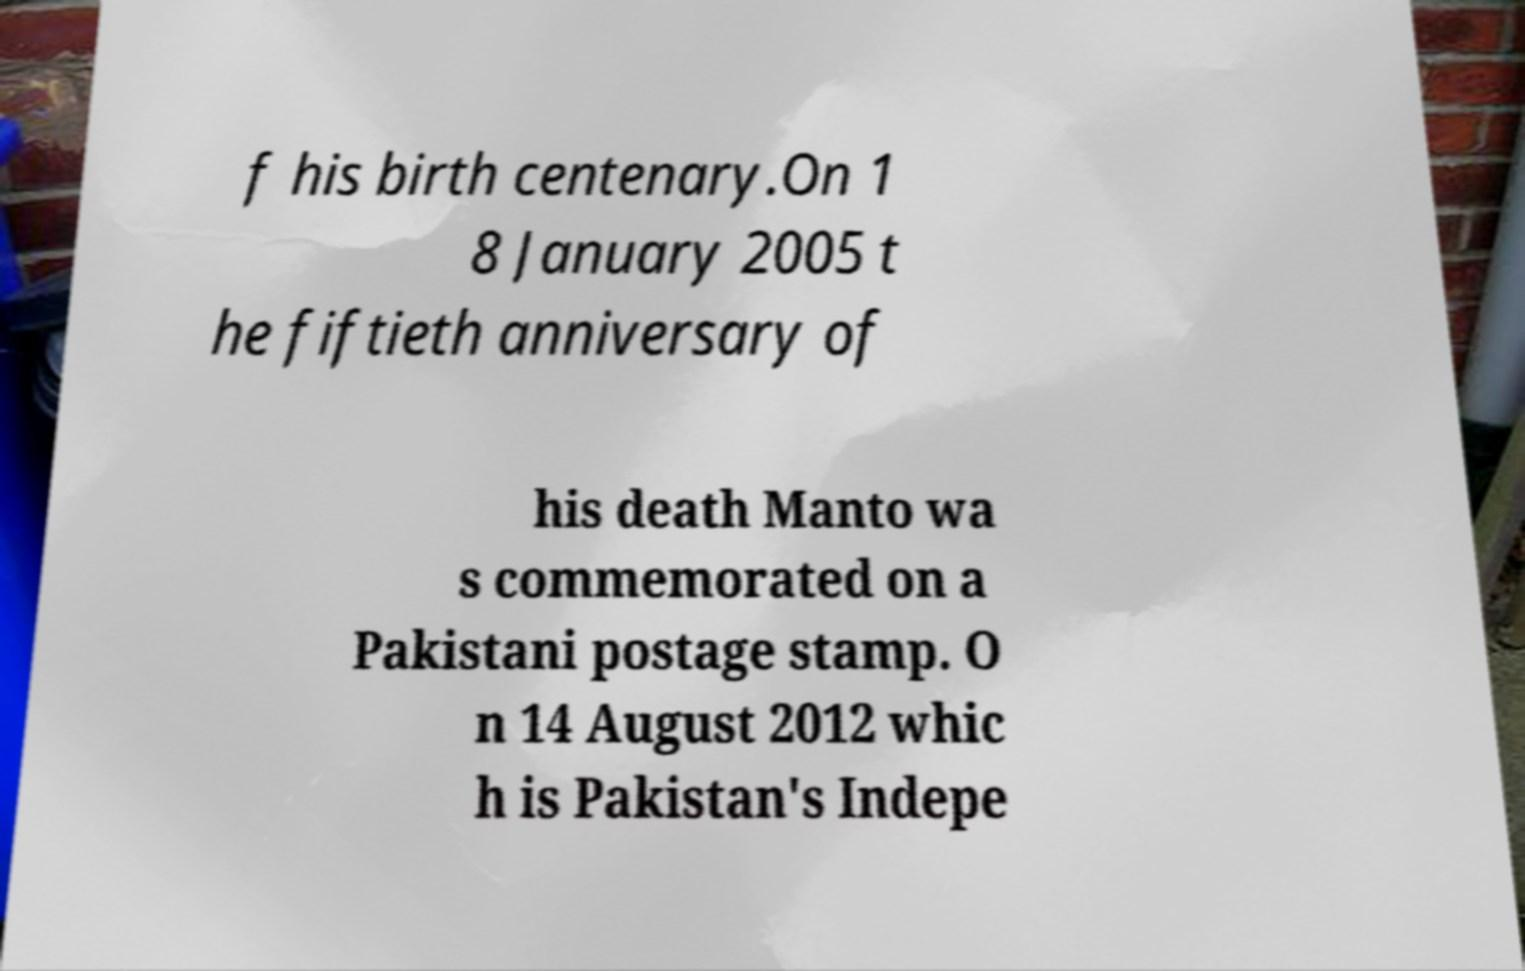Please identify and transcribe the text found in this image. f his birth centenary.On 1 8 January 2005 t he fiftieth anniversary of his death Manto wa s commemorated on a Pakistani postage stamp. O n 14 August 2012 whic h is Pakistan's Indepe 